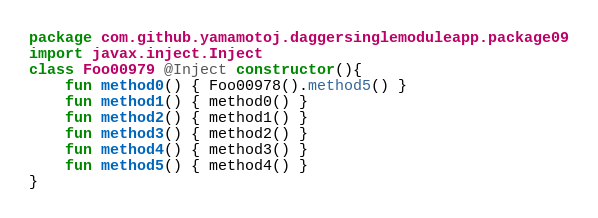<code> <loc_0><loc_0><loc_500><loc_500><_Kotlin_>package com.github.yamamotoj.daggersinglemoduleapp.package09
import javax.inject.Inject
class Foo00979 @Inject constructor(){
    fun method0() { Foo00978().method5() }
    fun method1() { method0() }
    fun method2() { method1() }
    fun method3() { method2() }
    fun method4() { method3() }
    fun method5() { method4() }
}
</code> 